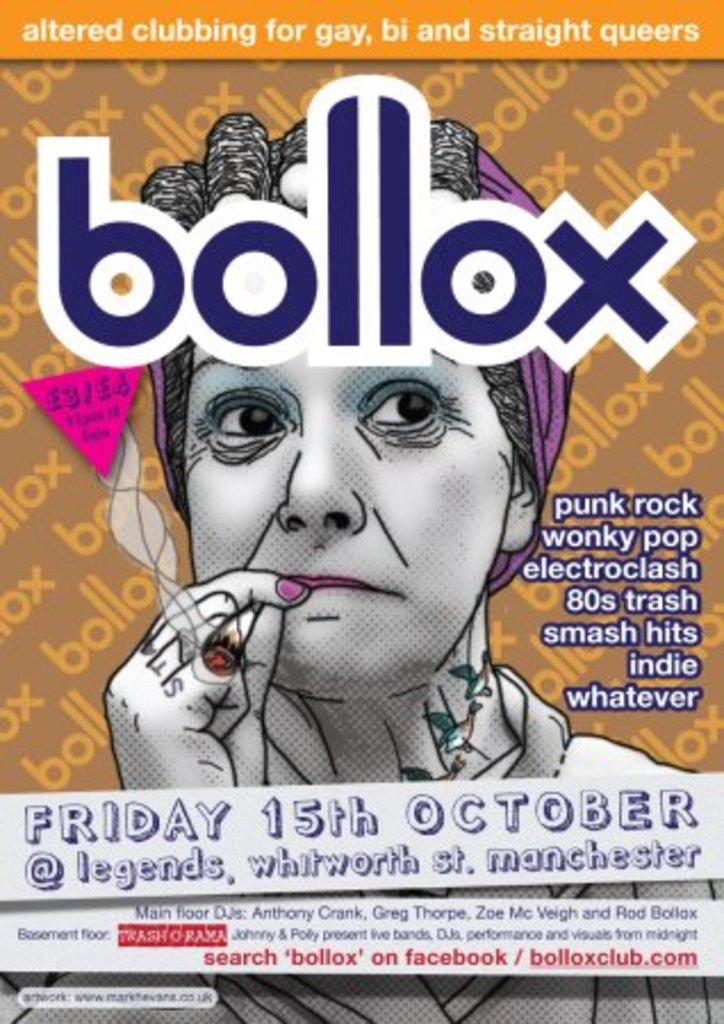<image>
Summarize the visual content of the image. Poster showing a woman smoking a cigarette and the name BOLLOX on the top. 